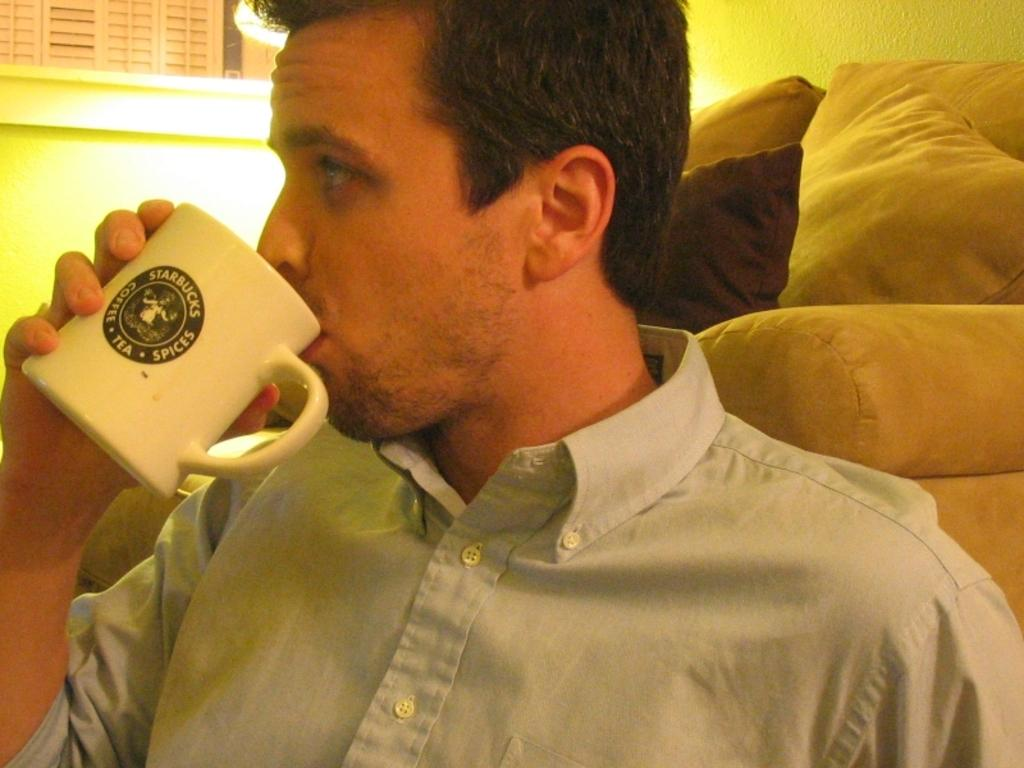Who is present in the image? There is a man in the image. What is the man holding in his hand? The man is holding a cup in his hand. What is the man doing with the cup? The man is drinking from the cup. What can be seen behind the man? There is a wall behind the man. What type of seating is visible in the image? There are pillows and cushions visible in the image. What type of bone can be seen in the man's hand in the image? There is no bone present in the man's hand in the image; he is holding a cup. How many sheep are visible in the image? There are no sheep present in the image. 